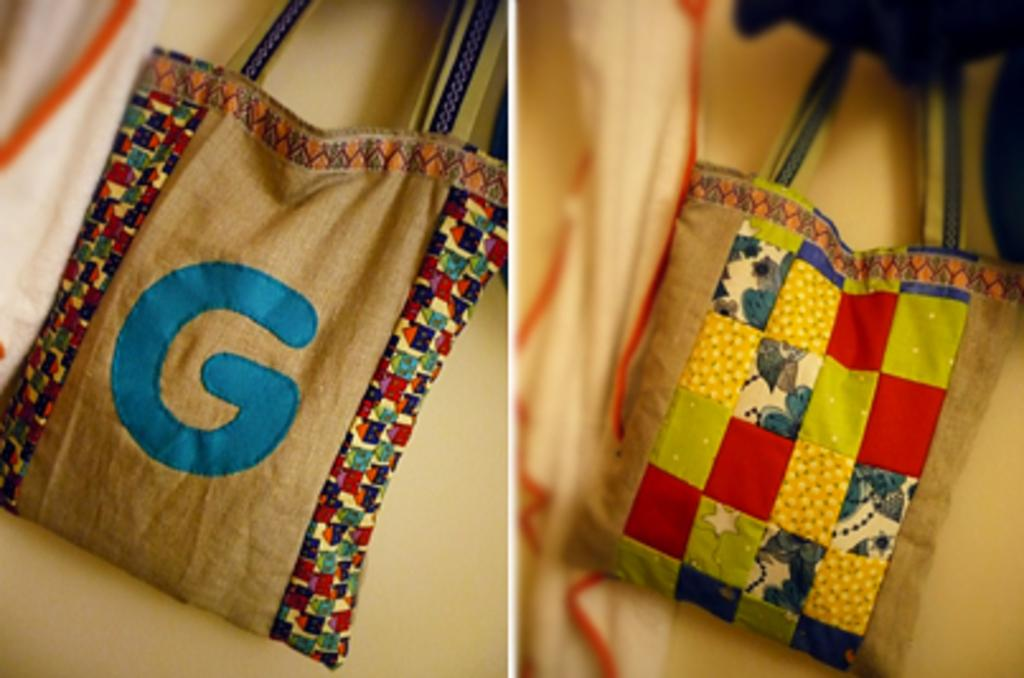How many bags are visible in the image? There are two bags in the image. What type of image is being described? The image is a collage. How many sisters are depicted in the image? There are no sisters depicted in the image; it only features two bags in a collage. What type of writer is shown working in the image? There is no writer present in the image; it only contains two bags and is a collage. 